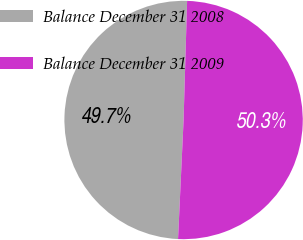Convert chart. <chart><loc_0><loc_0><loc_500><loc_500><pie_chart><fcel>Balance December 31 2008<fcel>Balance December 31 2009<nl><fcel>49.73%<fcel>50.27%<nl></chart> 